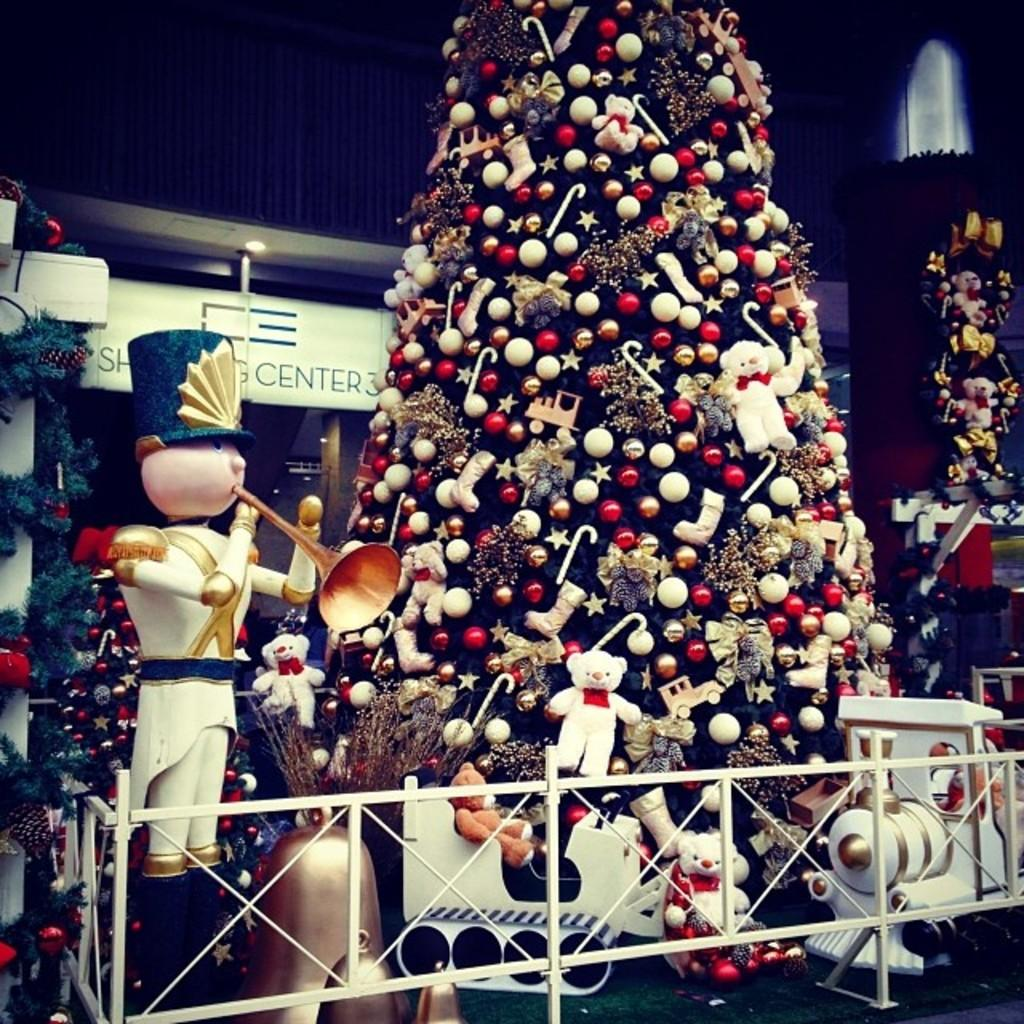What type of decorations are present in the image? There are Christmas trees in the image. What other items can be seen in the image? There are toys and a toy train visible in the image. What is the purpose of the railing in the image? The railing is likely used for safety or support. What can be seen in the background of the image? There are lights and a wall visible in the background. What type of stove is visible in the image? There is no stove present in the image. How many eyes can be seen on the Christmas trees in the image? Christmas trees do not have eyes, so this question cannot be answered. 